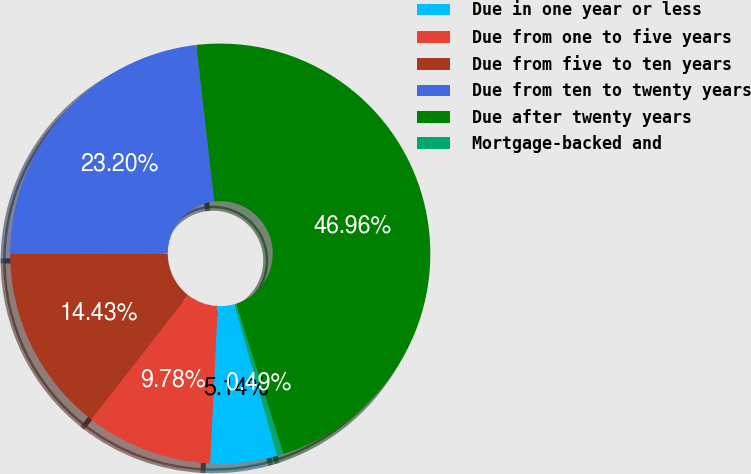<chart> <loc_0><loc_0><loc_500><loc_500><pie_chart><fcel>Due in one year or less<fcel>Due from one to five years<fcel>Due from five to ten years<fcel>Due from ten to twenty years<fcel>Due after twenty years<fcel>Mortgage-backed and<nl><fcel>5.14%<fcel>9.78%<fcel>14.43%<fcel>23.2%<fcel>46.96%<fcel>0.49%<nl></chart> 